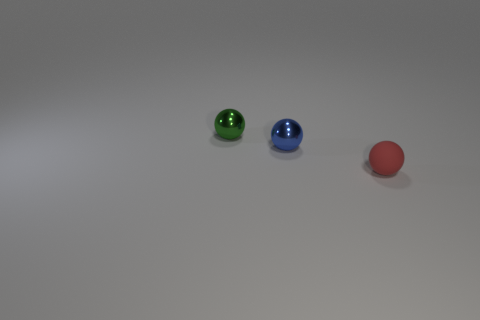Can you tell me about the lightning conditions in which this picture was taken? The lighting in the image seems to be soft and diffused, possibly suggesting an indoor shoot with either ample natural light coming from a nearby window or well-dispersed artificial light to minimize harsh shadows. 